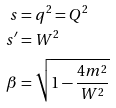<formula> <loc_0><loc_0><loc_500><loc_500>s & = q ^ { 2 } = Q ^ { 2 } \\ s ^ { \prime } & = W ^ { 2 } \\ \beta & = \sqrt { 1 - \frac { 4 m ^ { 2 } } { W ^ { 2 } } }</formula> 